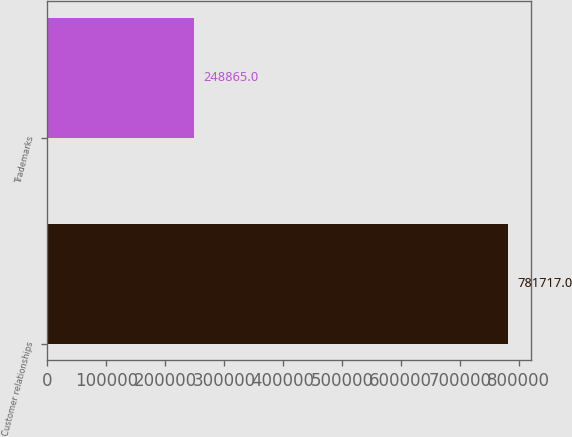Convert chart. <chart><loc_0><loc_0><loc_500><loc_500><bar_chart><fcel>Customer relationships<fcel>Trademarks<nl><fcel>781717<fcel>248865<nl></chart> 